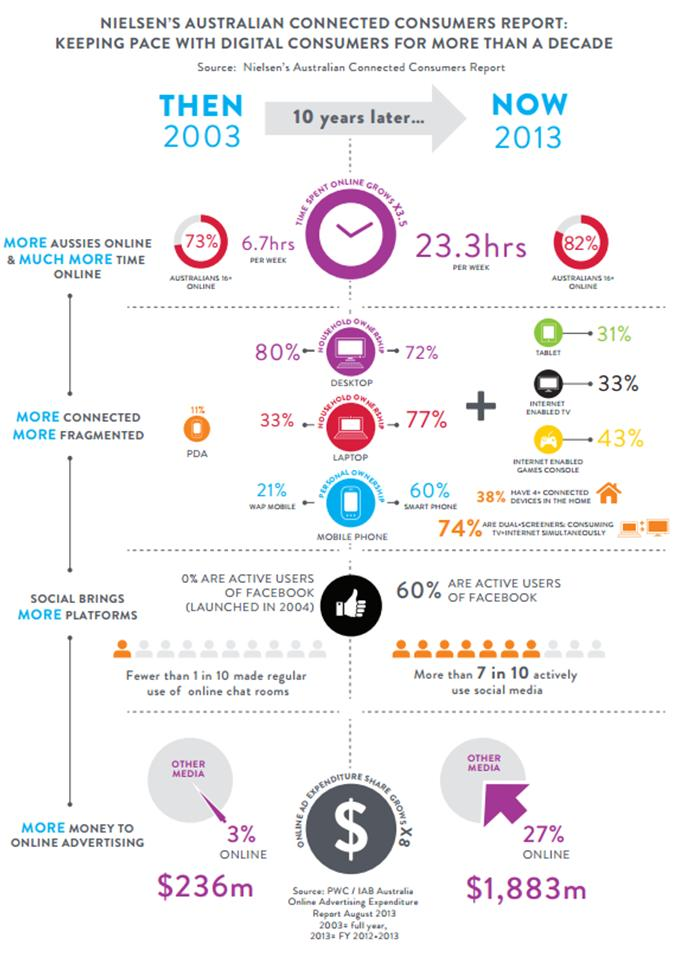Point out several critical features in this image. Internet-enabled games consoles are becoming increasingly connected to the internet. The ownership of desktop computers by households decreased in 2013. In the past 10 years, the amount of time spent online has increased by an additional 16.6 hours per week on average. Online advertising expenditures increased by $1,647 million from 2003 to 2010. The percentage of Australians who were online increased by 9% from 2003 to 2013. 